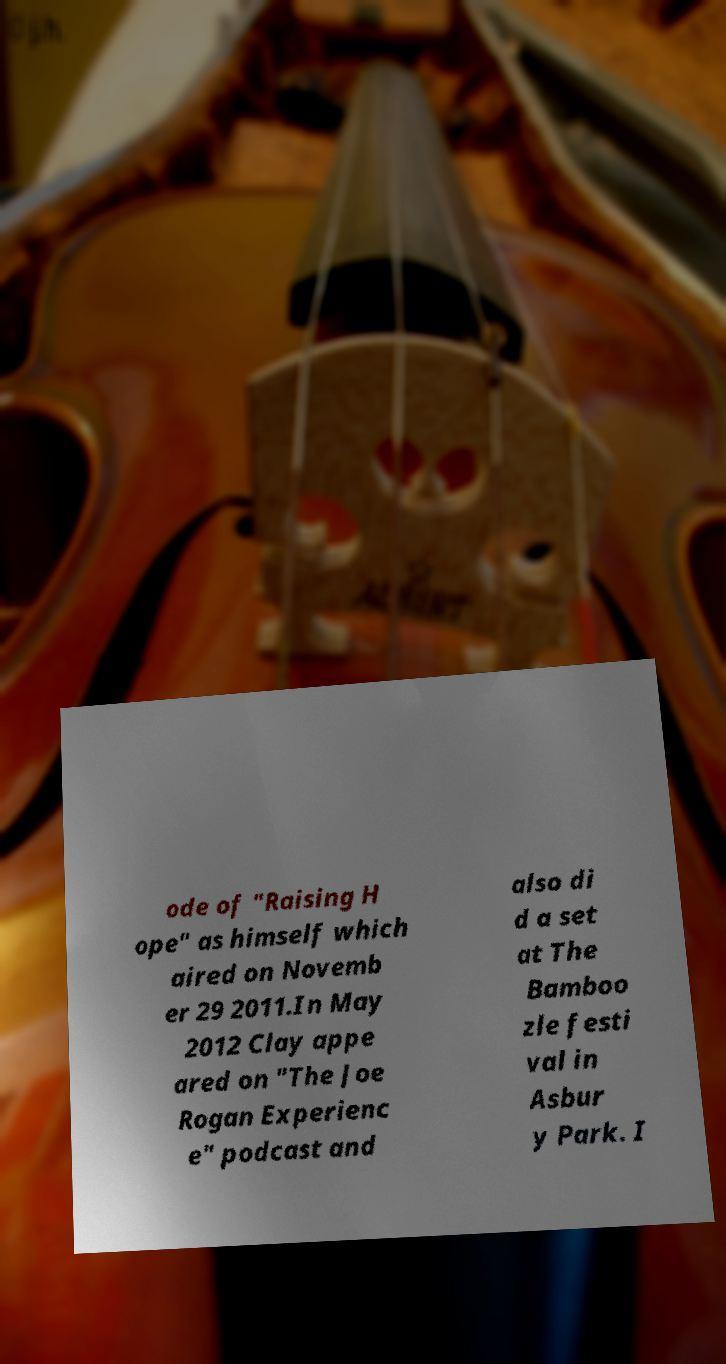Can you accurately transcribe the text from the provided image for me? ode of "Raising H ope" as himself which aired on Novemb er 29 2011.In May 2012 Clay appe ared on "The Joe Rogan Experienc e" podcast and also di d a set at The Bamboo zle festi val in Asbur y Park. I 